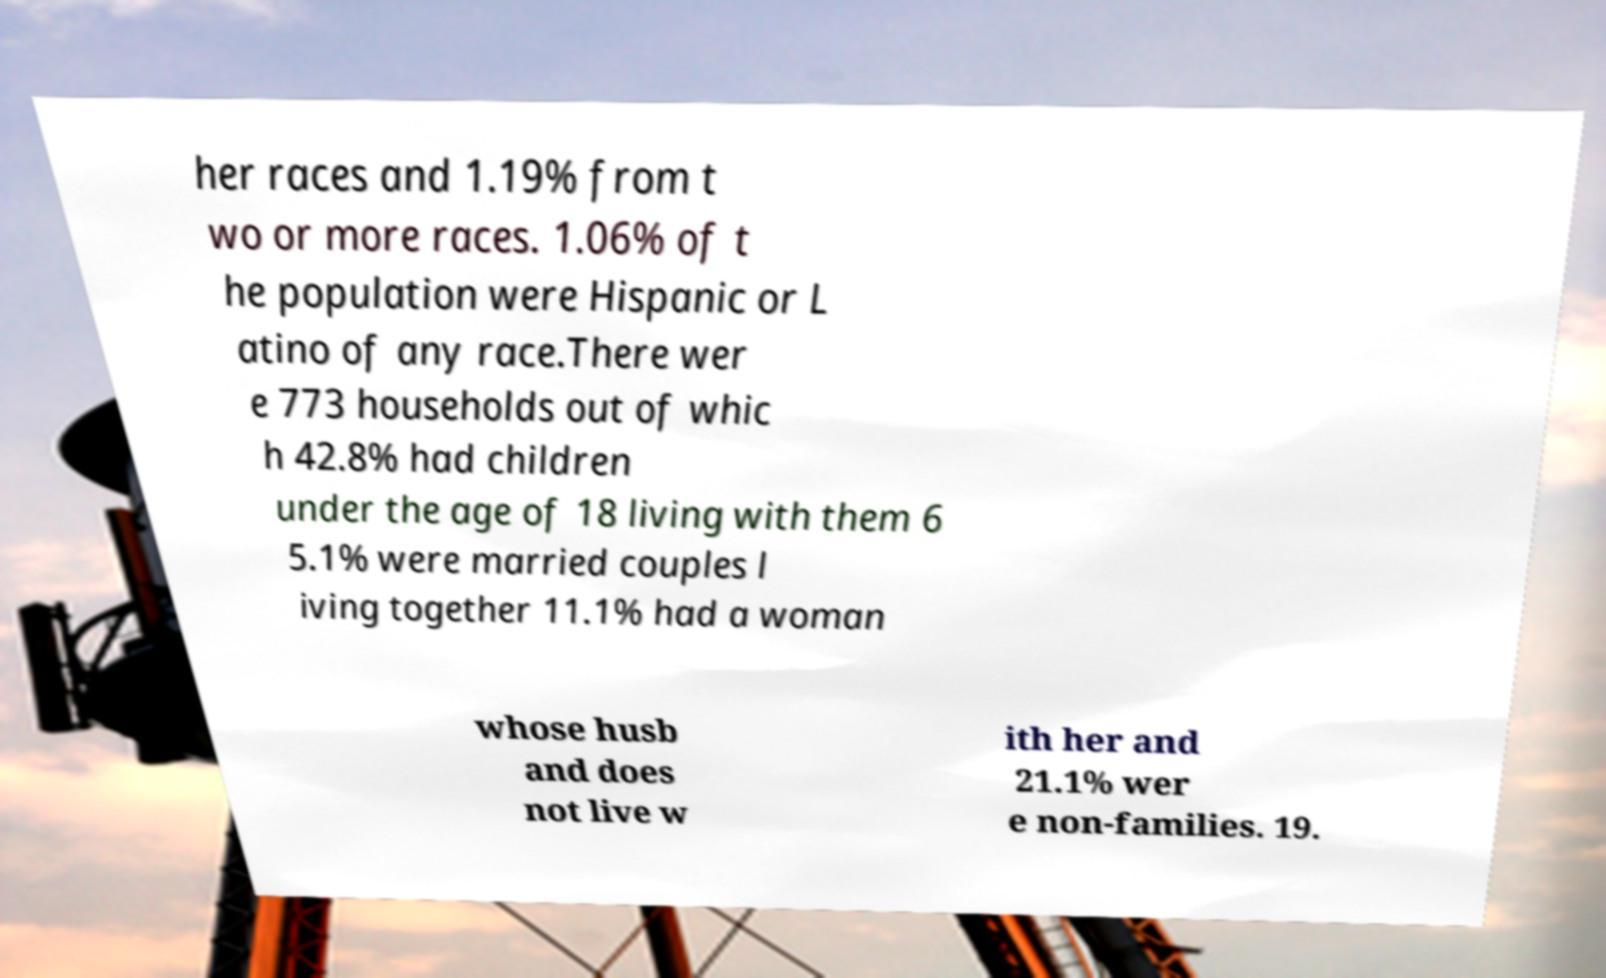I need the written content from this picture converted into text. Can you do that? her races and 1.19% from t wo or more races. 1.06% of t he population were Hispanic or L atino of any race.There wer e 773 households out of whic h 42.8% had children under the age of 18 living with them 6 5.1% were married couples l iving together 11.1% had a woman whose husb and does not live w ith her and 21.1% wer e non-families. 19. 